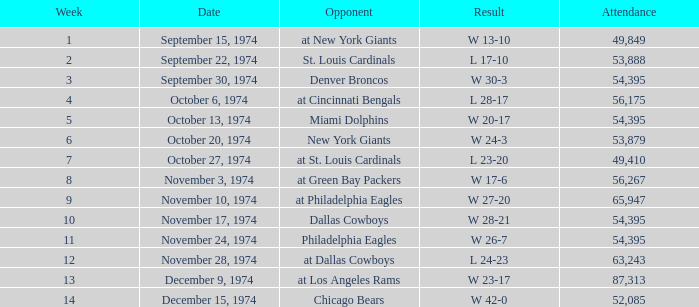What is the week of the game occurring on november 28, 1974? 12.0. 